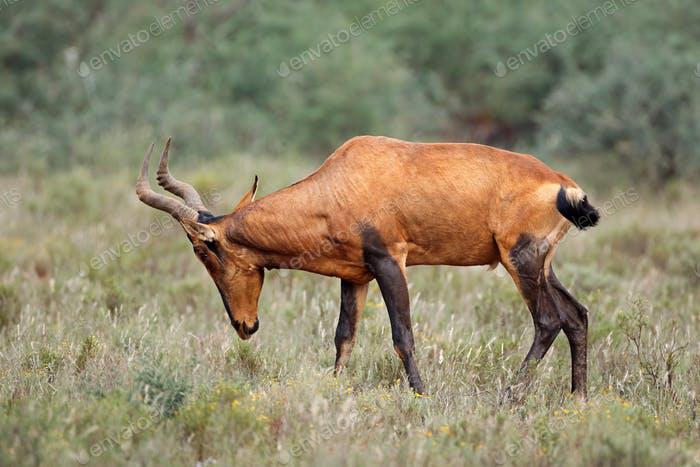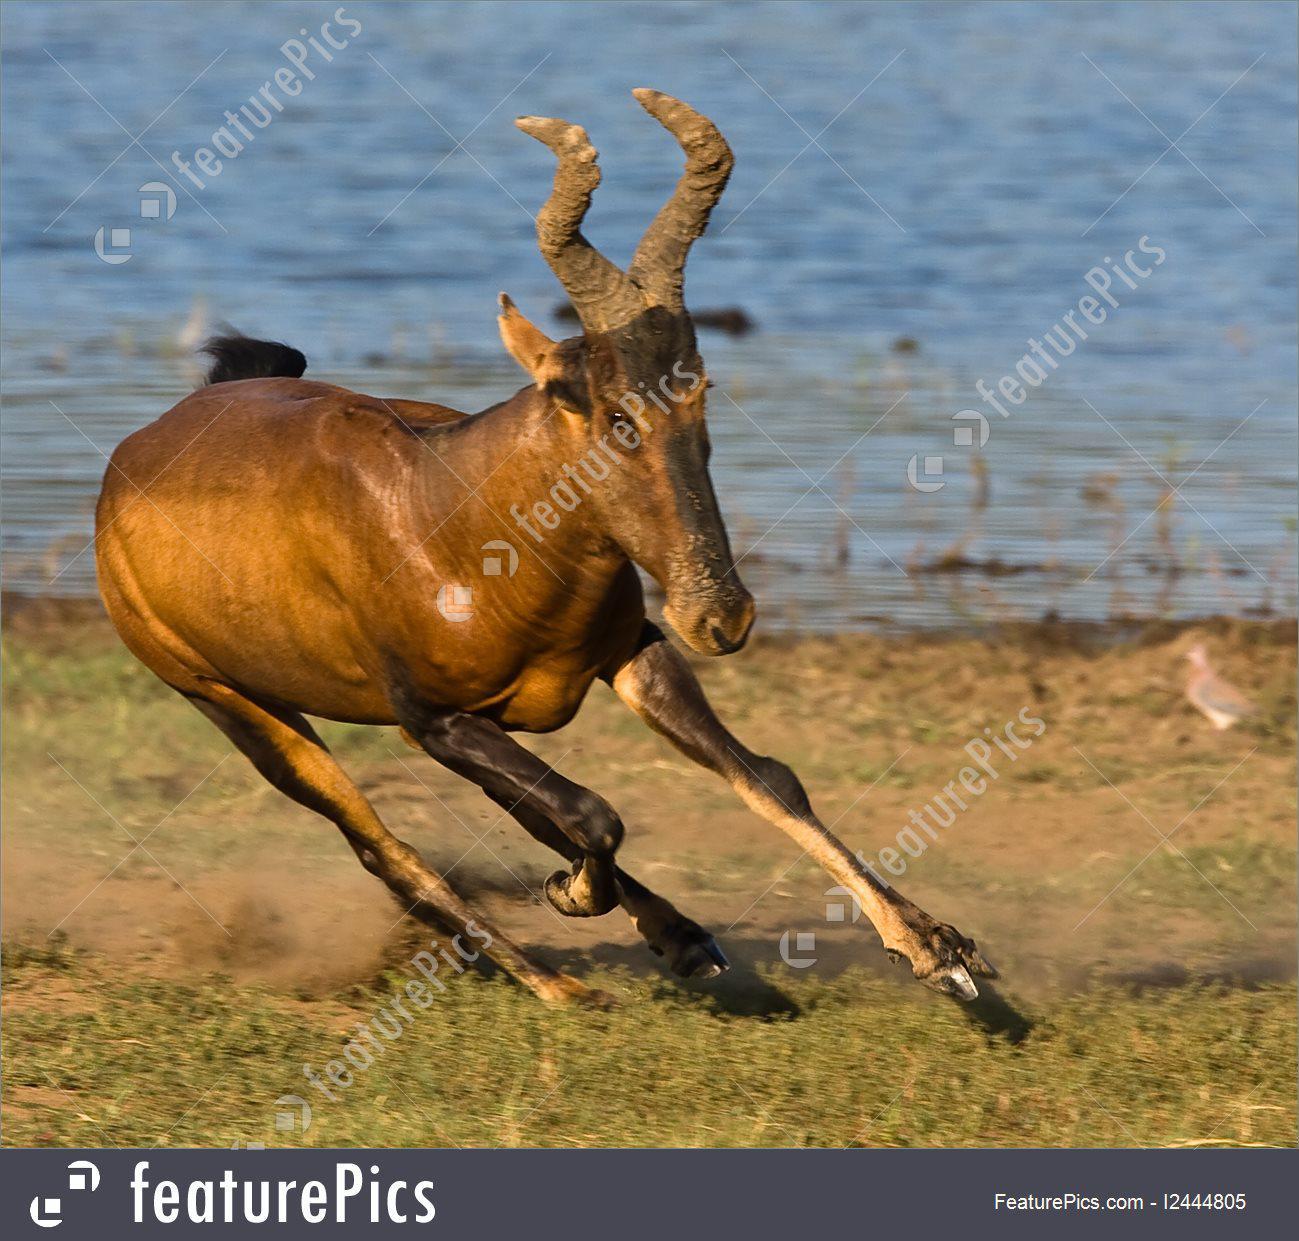The first image is the image on the left, the second image is the image on the right. For the images displayed, is the sentence "The left and right image contains the same number of antelopes." factually correct? Answer yes or no. Yes. The first image is the image on the left, the second image is the image on the right. Assess this claim about the two images: "The left image shows an animal facing to the right.". Correct or not? Answer yes or no. No. 